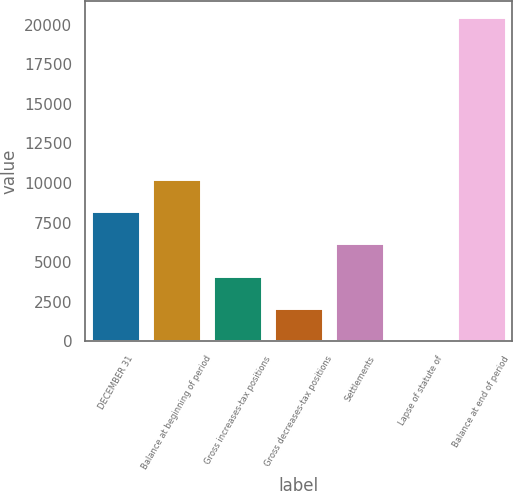<chart> <loc_0><loc_0><loc_500><loc_500><bar_chart><fcel>DECEMBER 31<fcel>Balance at beginning of period<fcel>Gross increases-tax positions<fcel>Gross decreases-tax positions<fcel>Settlements<fcel>Lapse of statute of<fcel>Balance at end of period<nl><fcel>8230<fcel>10272.5<fcel>4145<fcel>2102.5<fcel>6187.5<fcel>60<fcel>20485<nl></chart> 